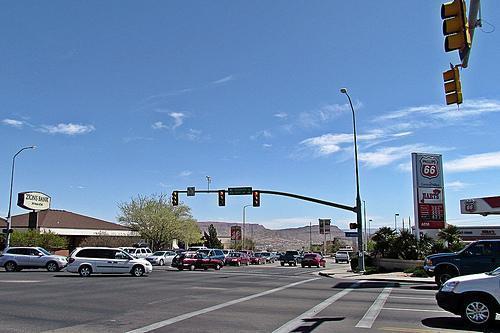How many stop lights in the picure?
Give a very brief answer. 3. 